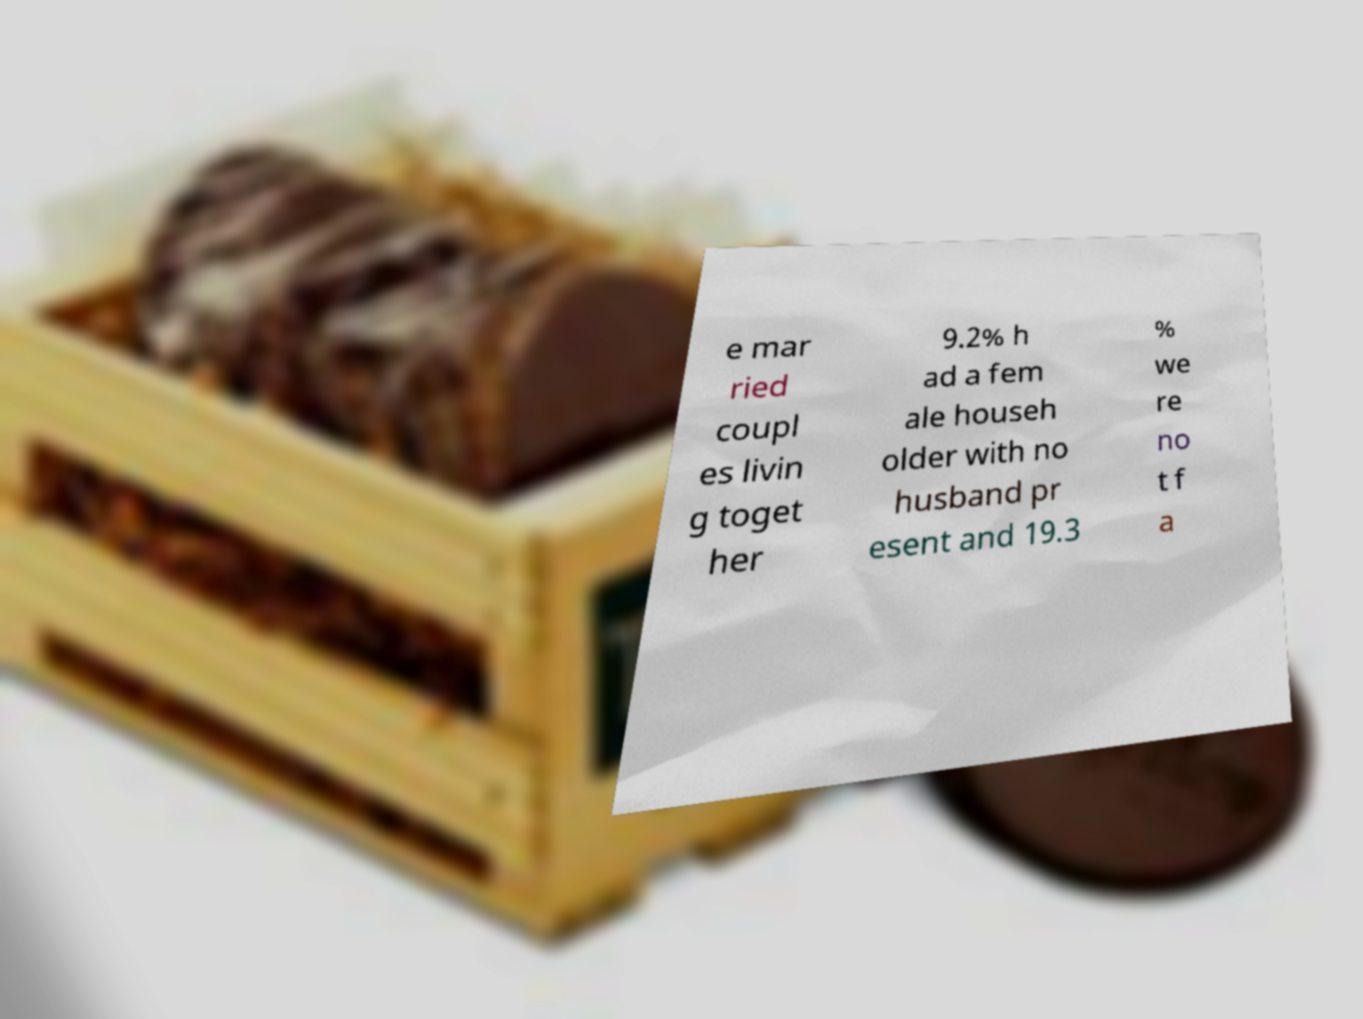For documentation purposes, I need the text within this image transcribed. Could you provide that? e mar ried coupl es livin g toget her 9.2% h ad a fem ale househ older with no husband pr esent and 19.3 % we re no t f a 